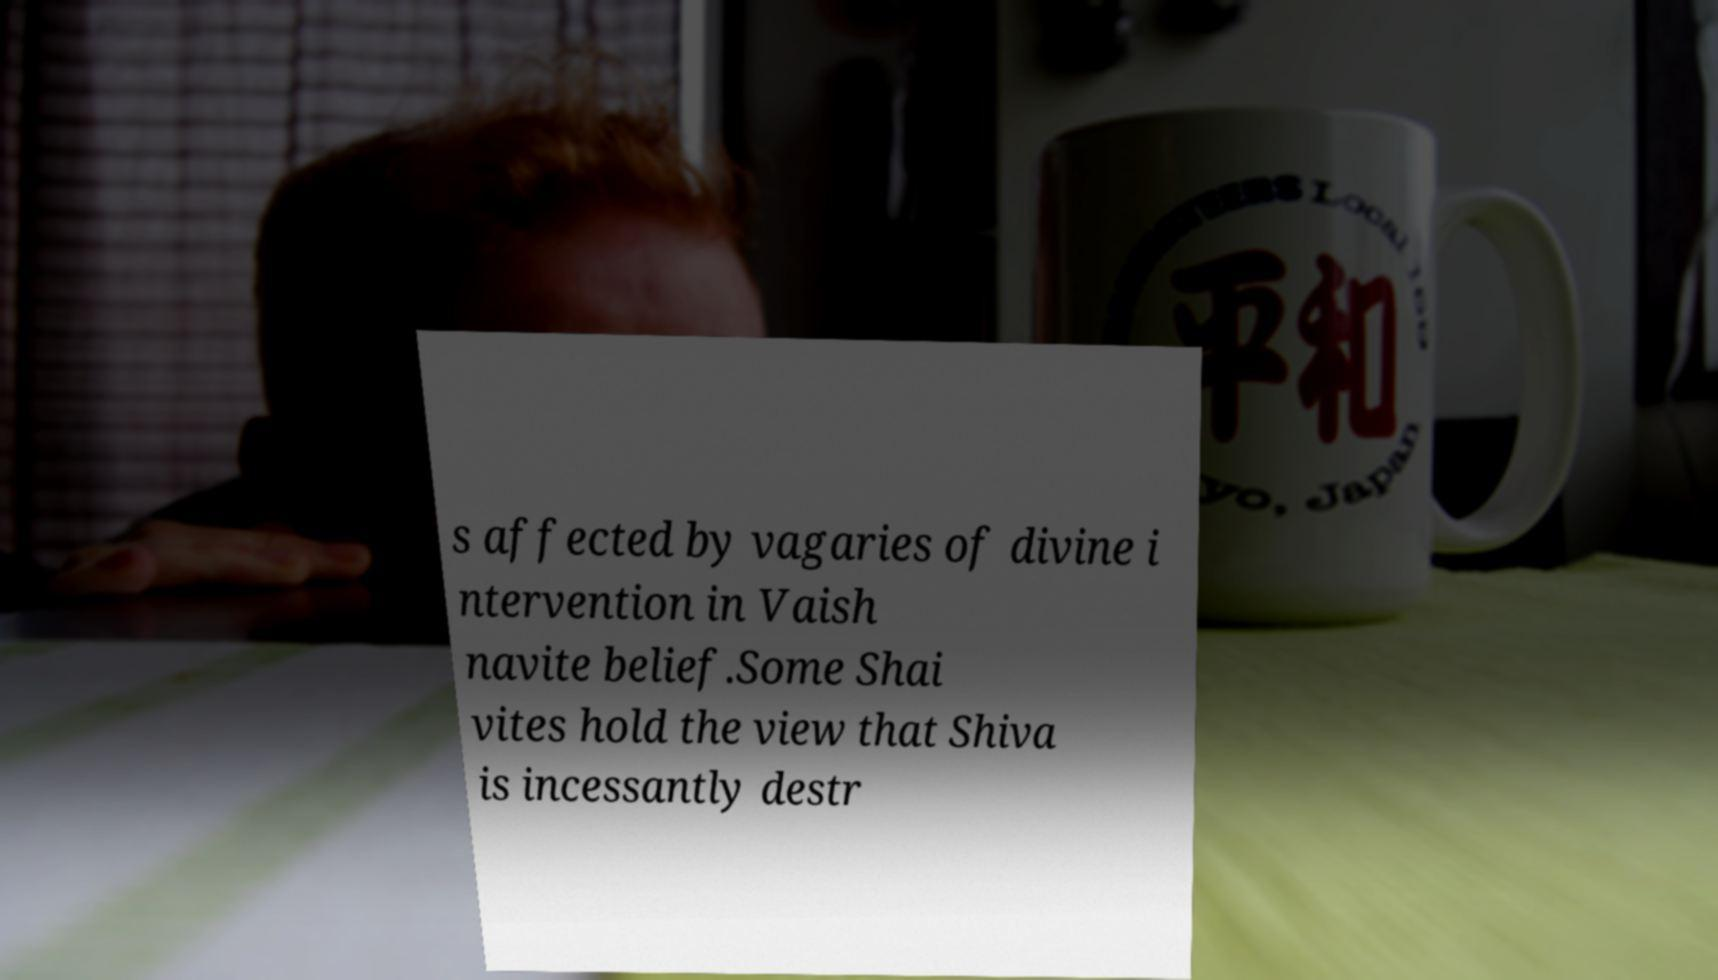Can you read and provide the text displayed in the image?This photo seems to have some interesting text. Can you extract and type it out for me? s affected by vagaries of divine i ntervention in Vaish navite belief.Some Shai vites hold the view that Shiva is incessantly destr 